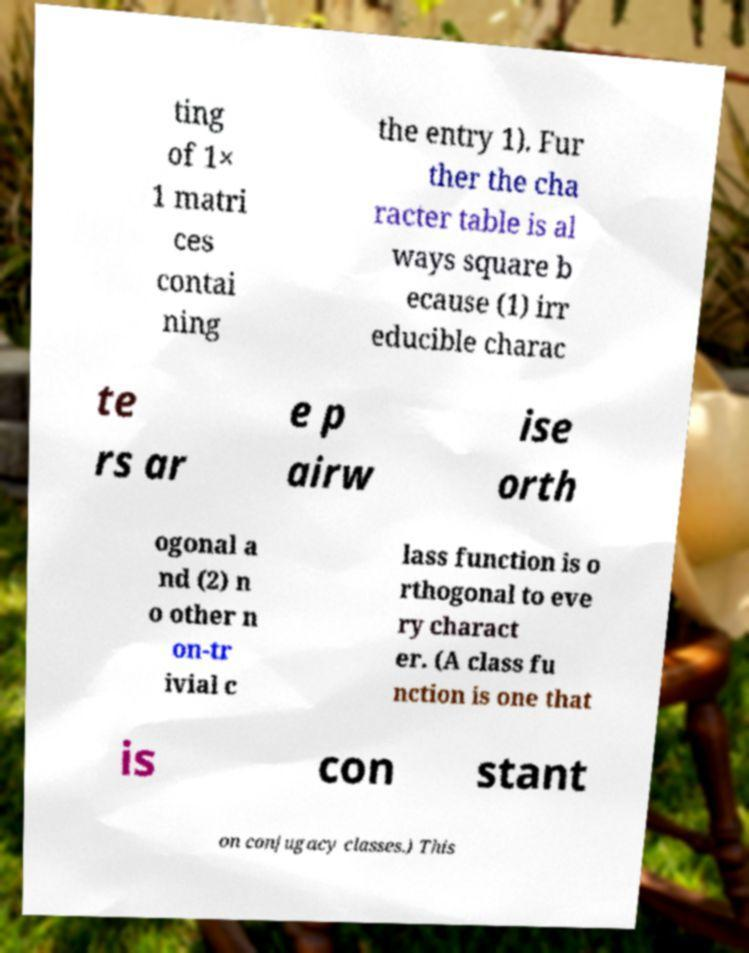For documentation purposes, I need the text within this image transcribed. Could you provide that? ting of 1× 1 matri ces contai ning the entry 1). Fur ther the cha racter table is al ways square b ecause (1) irr educible charac te rs ar e p airw ise orth ogonal a nd (2) n o other n on-tr ivial c lass function is o rthogonal to eve ry charact er. (A class fu nction is one that is con stant on conjugacy classes.) This 